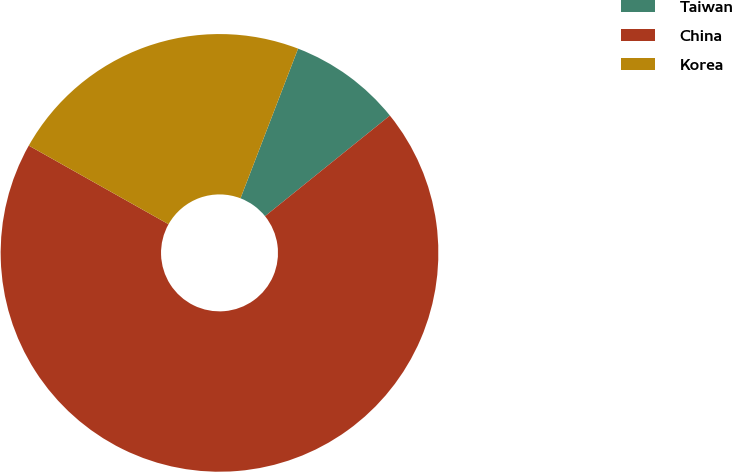<chart> <loc_0><loc_0><loc_500><loc_500><pie_chart><fcel>Taiwan<fcel>China<fcel>Korea<nl><fcel>8.36%<fcel>68.96%<fcel>22.69%<nl></chart> 